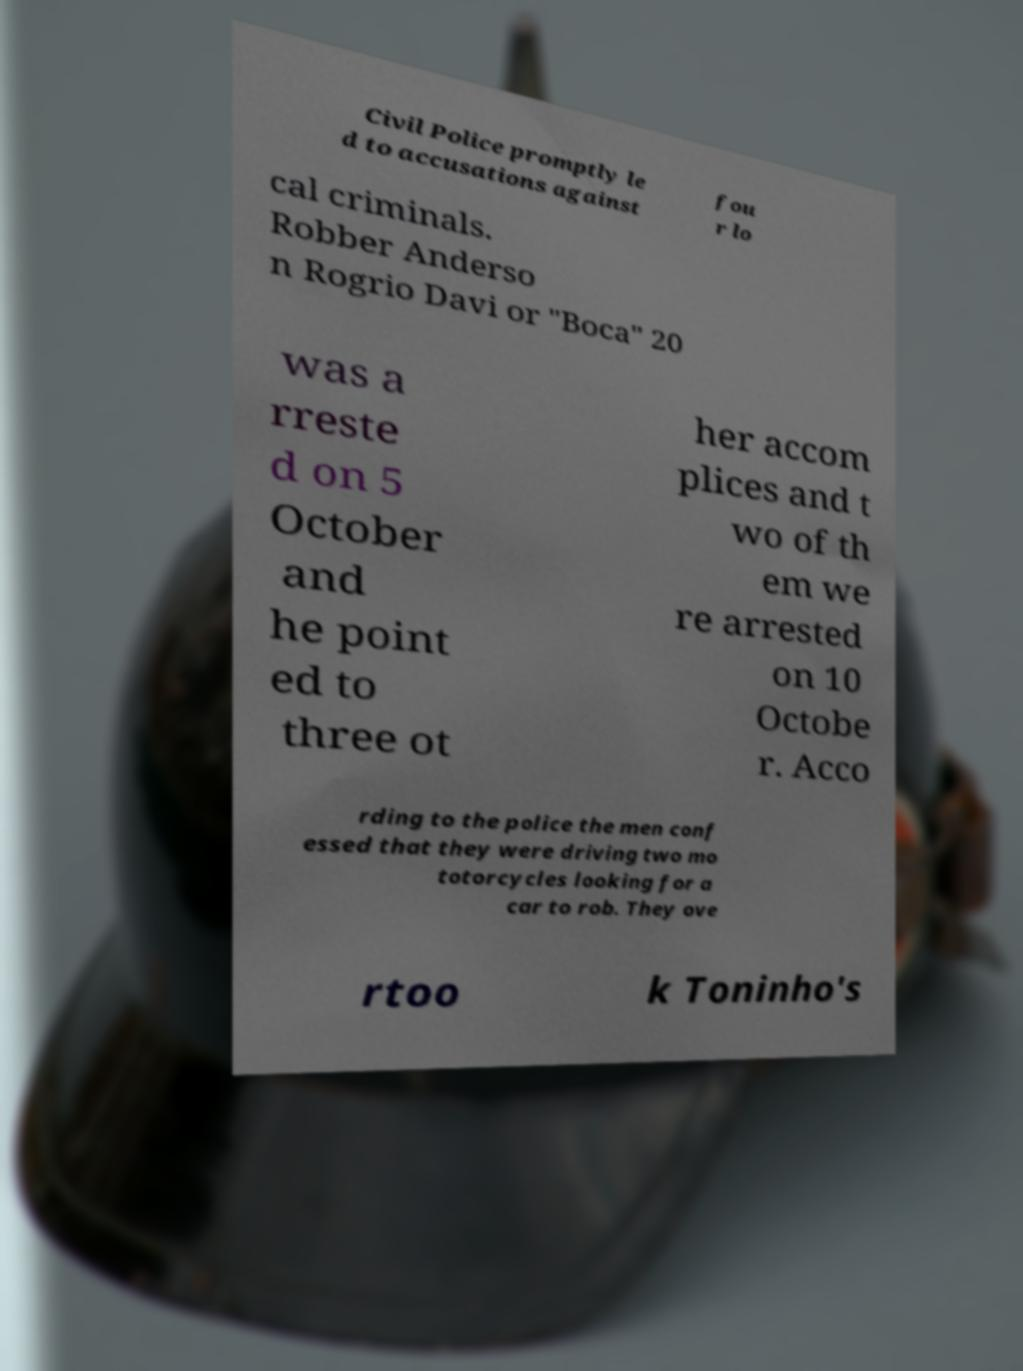Please identify and transcribe the text found in this image. Civil Police promptly le d to accusations against fou r lo cal criminals. Robber Anderso n Rogrio Davi or "Boca" 20 was a rreste d on 5 October and he point ed to three ot her accom plices and t wo of th em we re arrested on 10 Octobe r. Acco rding to the police the men conf essed that they were driving two mo totorcycles looking for a car to rob. They ove rtoo k Toninho's 